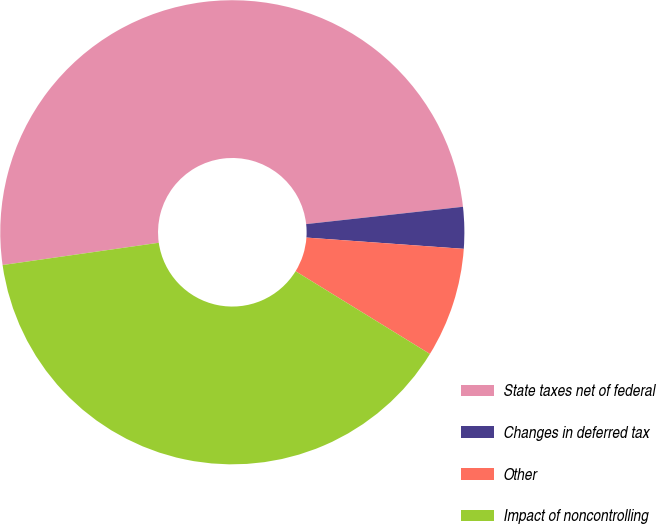Convert chart to OTSL. <chart><loc_0><loc_0><loc_500><loc_500><pie_chart><fcel>State taxes net of federal<fcel>Changes in deferred tax<fcel>Other<fcel>Impact of noncontrolling<nl><fcel>50.51%<fcel>2.89%<fcel>7.65%<fcel>38.96%<nl></chart> 